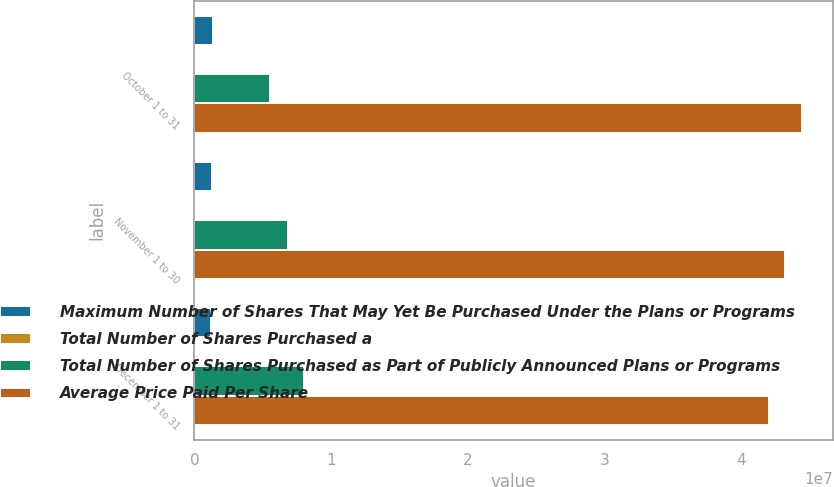Convert chart to OTSL. <chart><loc_0><loc_0><loc_500><loc_500><stacked_bar_chart><ecel><fcel>October 1 to 31<fcel>November 1 to 30<fcel>December 1 to 31<nl><fcel>Maximum Number of Shares That May Yet Be Purchased Under the Plans or Programs<fcel>1.392e+06<fcel>1.281e+06<fcel>1.199e+06<nl><fcel>Total Number of Shares Purchased a<fcel>69.95<fcel>68.97<fcel>69.25<nl><fcel>Total Number of Shares Purchased as Part of Publicly Announced Plans or Programs<fcel>5.53441e+06<fcel>6.81541e+06<fcel>8.01441e+06<nl><fcel>Average Price Paid Per Share<fcel>4.44656e+07<fcel>4.31846e+07<fcel>4.19856e+07<nl></chart> 